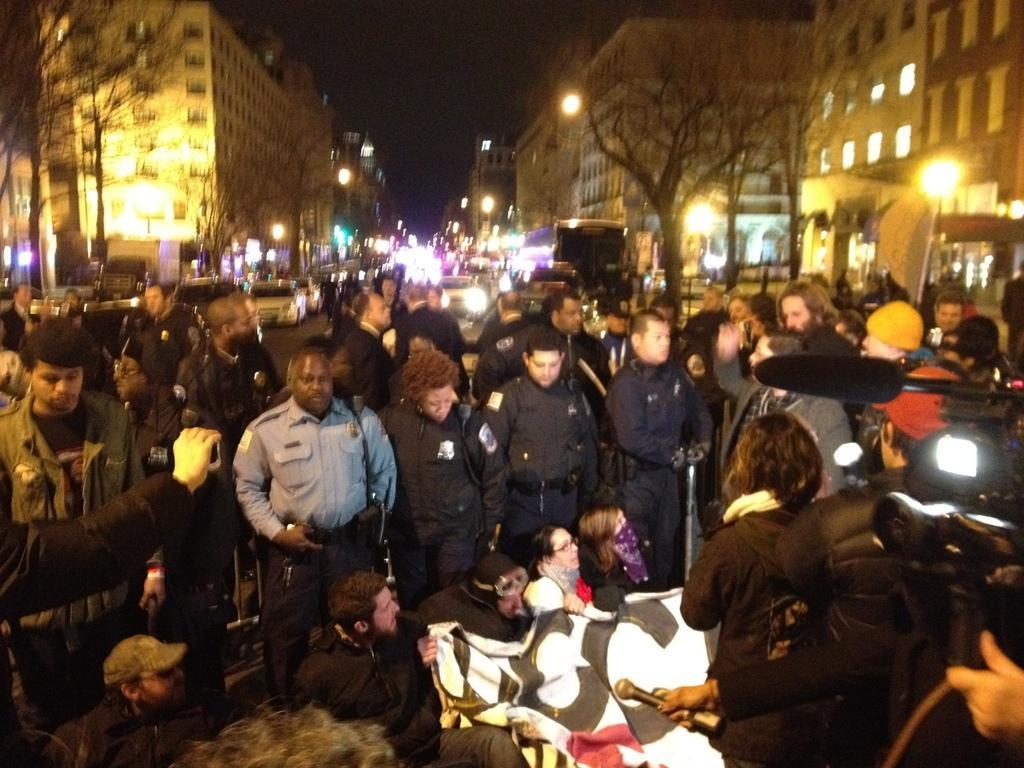In one or two sentences, can you explain what this image depicts? As we can see in the image there are group of people, cloth, camera, mic, street lamps, trees, buildings and at the top there is sky. The image is little dark. 